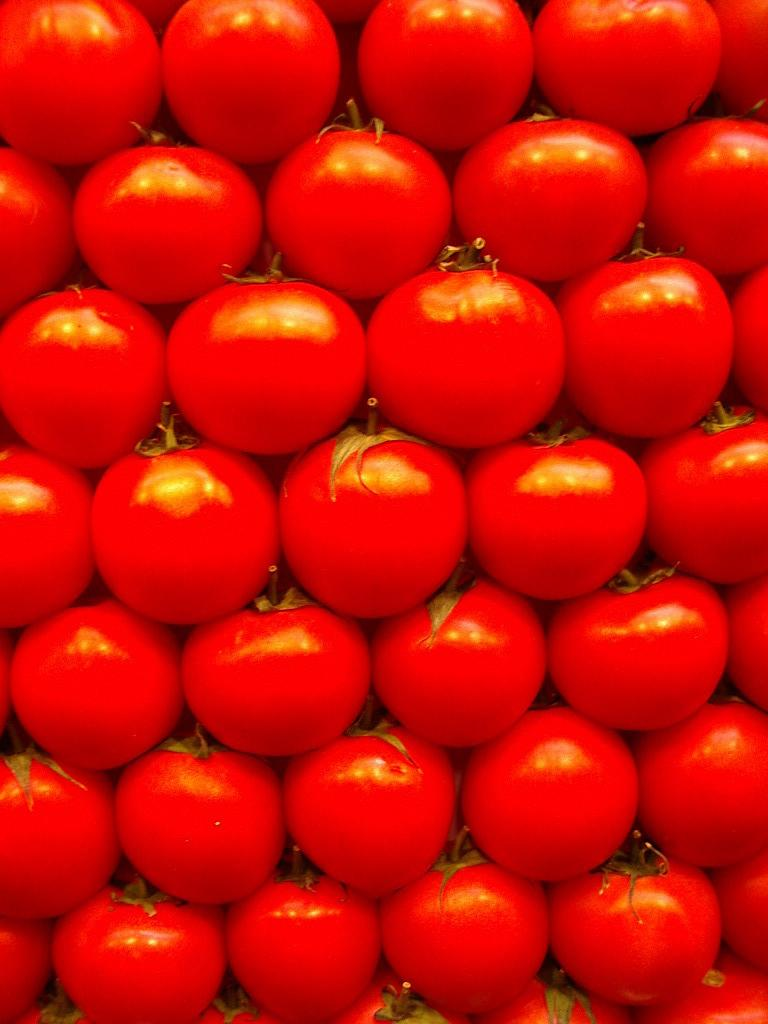What is the predominant color of the tomatoes in the image? The tomatoes in the image are predominantly red in color. How many tomatoes can be seen in the image? There are a lot of tomatoes visible in the image. What type of room can be seen in the background of the image? There is no room visible in the image; it only features tomatoes. Can you see a mountain in the distance in the image? There is no mountain visible in the image; it only features tomatoes. 